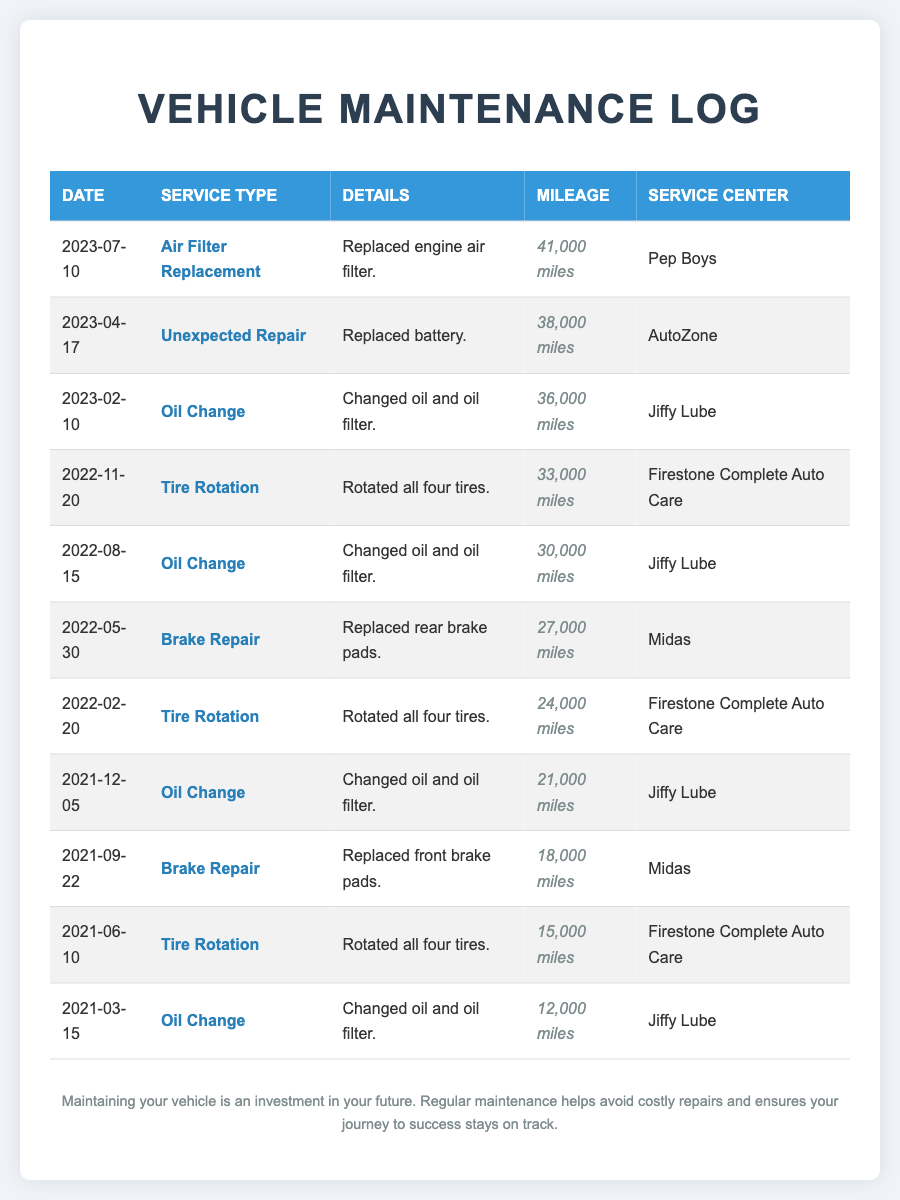What was the last service recorded? The last service recorded in the log is an Air Filter Replacement on July 10, 2023.
Answer: Air Filter Replacement What was the mileage at the time of the brake repair in May 2022? The mileage when the rear brake pads were replaced on May 30, 2022, was noted as 27,000 miles.
Answer: 27,000 miles Which service center performed the oil change on April 17, 2023? The oil change done on April 17, 2023, was performed at Jiffy Lube.
Answer: Jiffy Lube How many tire rotations were performed in the last three years? There were a total of three tire rotations recorded in the log over the past three years.
Answer: Three What type of unexpected repair was made in April 2023? The unexpected repair made in April 2023 involved replacing the battery.
Answer: Replaced battery What is the average mileage at which oil changes were performed? The mileage at which oil changes were conducted includes 12,000, 21,000, 30,000, 36,000, and 41,000 miles, which averages to 28,000 miles.
Answer: 28,000 miles What is the most common service type listed in the maintenance log? The most common service type listed in the maintenance log is Oil Change, with a total of four occurrences.
Answer: Oil Change What date was the first service recorded in the log? The first service recorded in the log was on March 15, 2021, for an oil change.
Answer: March 15, 2021 How many times were brake repairs conducted in the log? There were two instances of brake repairs recorded in the maintenance log.
Answer: Two 